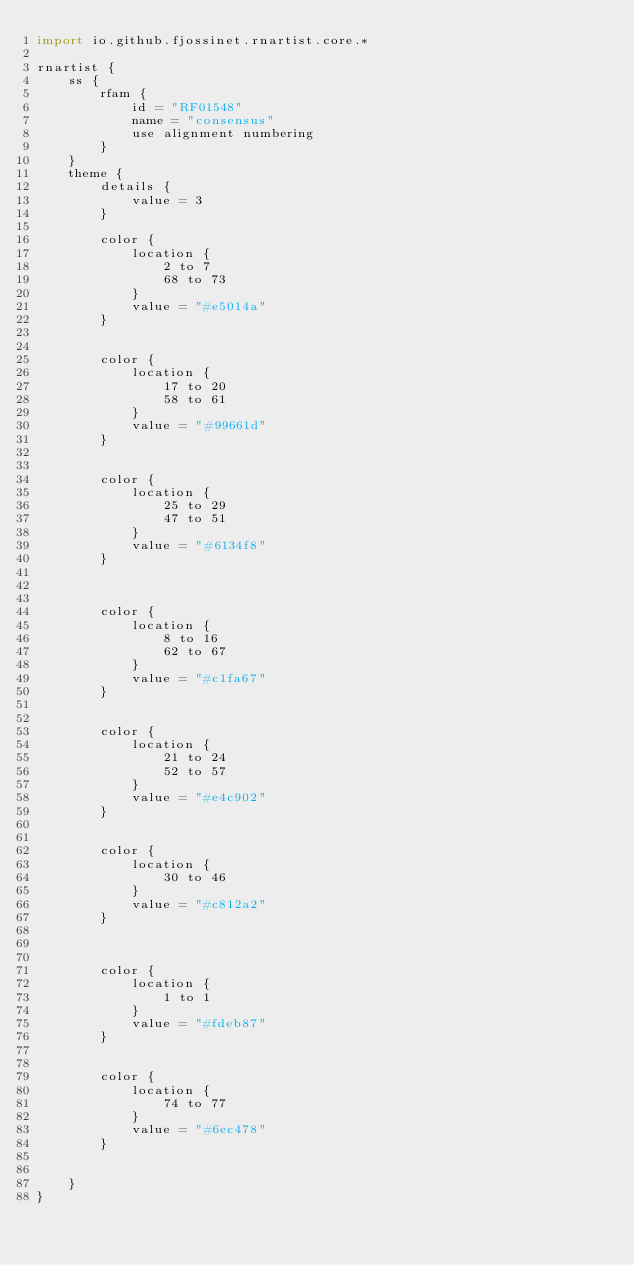<code> <loc_0><loc_0><loc_500><loc_500><_Kotlin_>import io.github.fjossinet.rnartist.core.*      

rnartist {
    ss {
        rfam {
            id = "RF01548"
            name = "consensus"
            use alignment numbering
        }
    }
    theme {
        details { 
            value = 3
        }

        color {
            location {
                2 to 7
                68 to 73
            }
            value = "#e5014a"
        }


        color {
            location {
                17 to 20
                58 to 61
            }
            value = "#99661d"
        }


        color {
            location {
                25 to 29
                47 to 51
            }
            value = "#6134f8"
        }



        color {
            location {
                8 to 16
                62 to 67
            }
            value = "#c1fa67"
        }


        color {
            location {
                21 to 24
                52 to 57
            }
            value = "#e4c902"
        }


        color {
            location {
                30 to 46
            }
            value = "#c812a2"
        }



        color {
            location {
                1 to 1
            }
            value = "#fdeb87"
        }


        color {
            location {
                74 to 77
            }
            value = "#6ec478"
        }


    }
}           </code> 